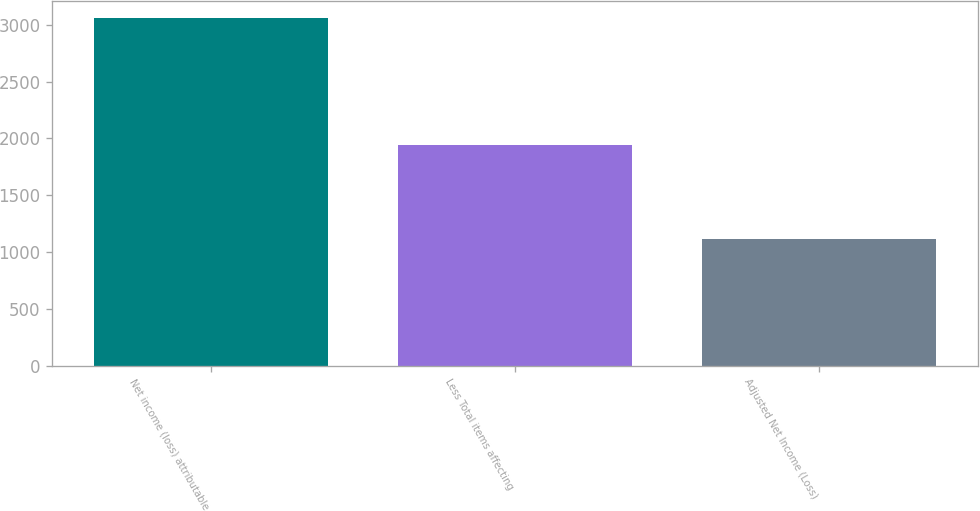Convert chart. <chart><loc_0><loc_0><loc_500><loc_500><bar_chart><fcel>Net income (loss) attributable<fcel>Less Total items affecting<fcel>Adjusted Net Income (Loss)<nl><fcel>3056<fcel>1943<fcel>1113<nl></chart> 